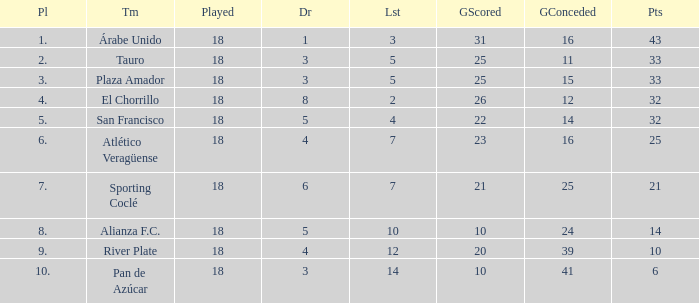How many points did the team have that conceded 41 goals and finish in a place larger than 10? 0.0. 